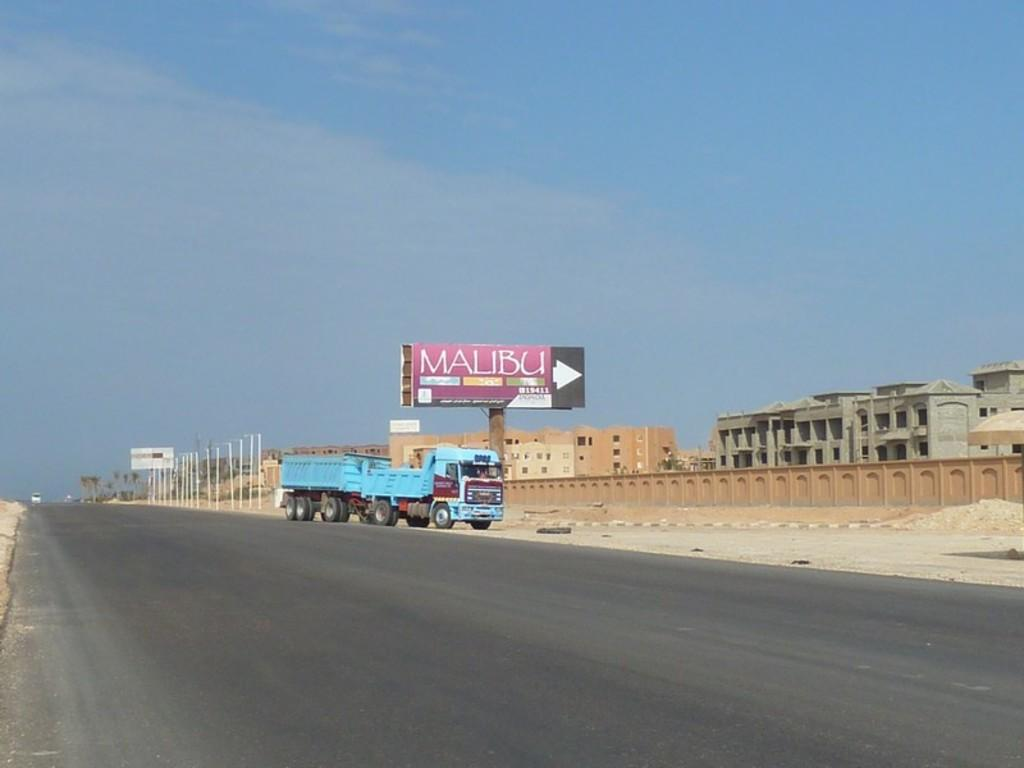Provide a one-sentence caption for the provided image. Blue truck is parked on the side of the road by the Malibu side. 